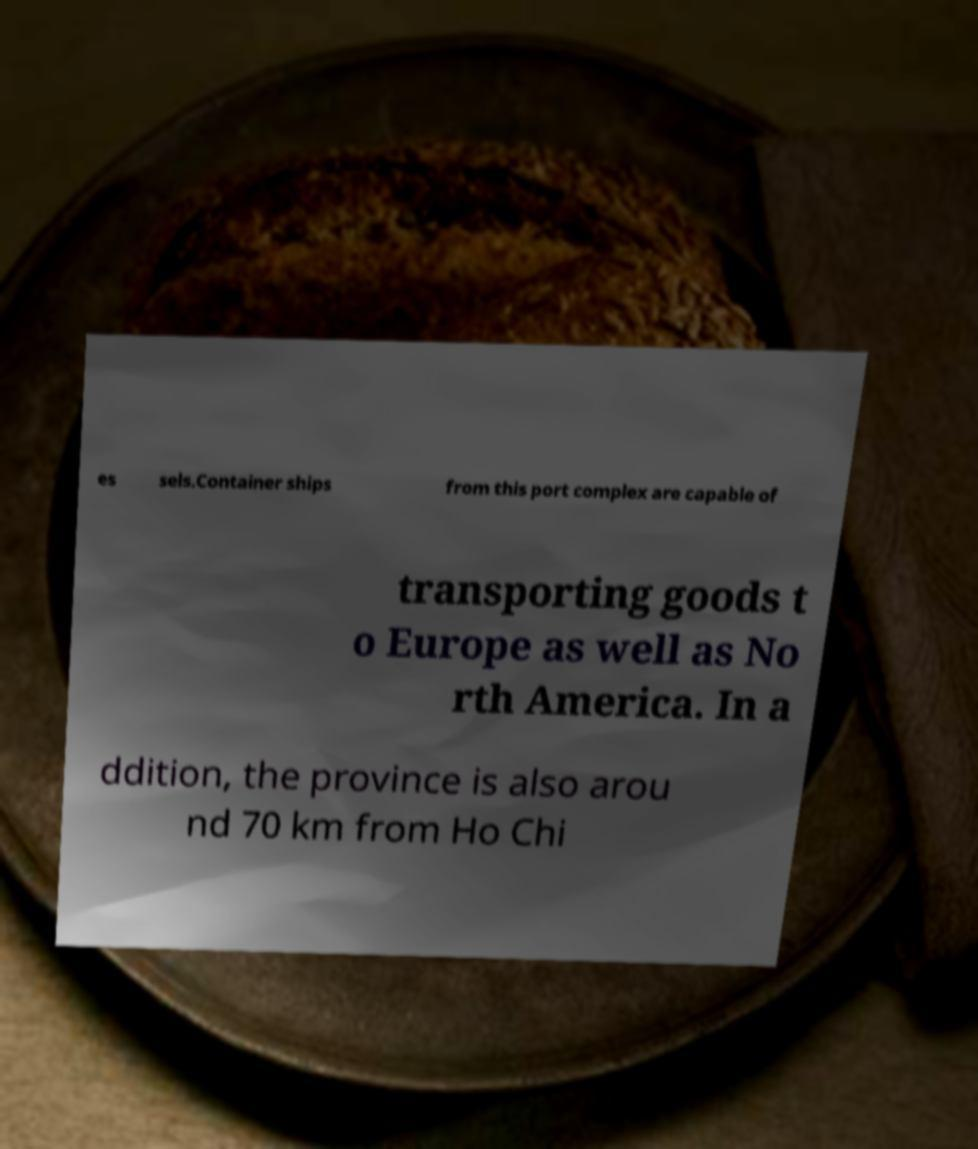For documentation purposes, I need the text within this image transcribed. Could you provide that? es sels.Container ships from this port complex are capable of transporting goods t o Europe as well as No rth America. In a ddition, the province is also arou nd 70 km from Ho Chi 